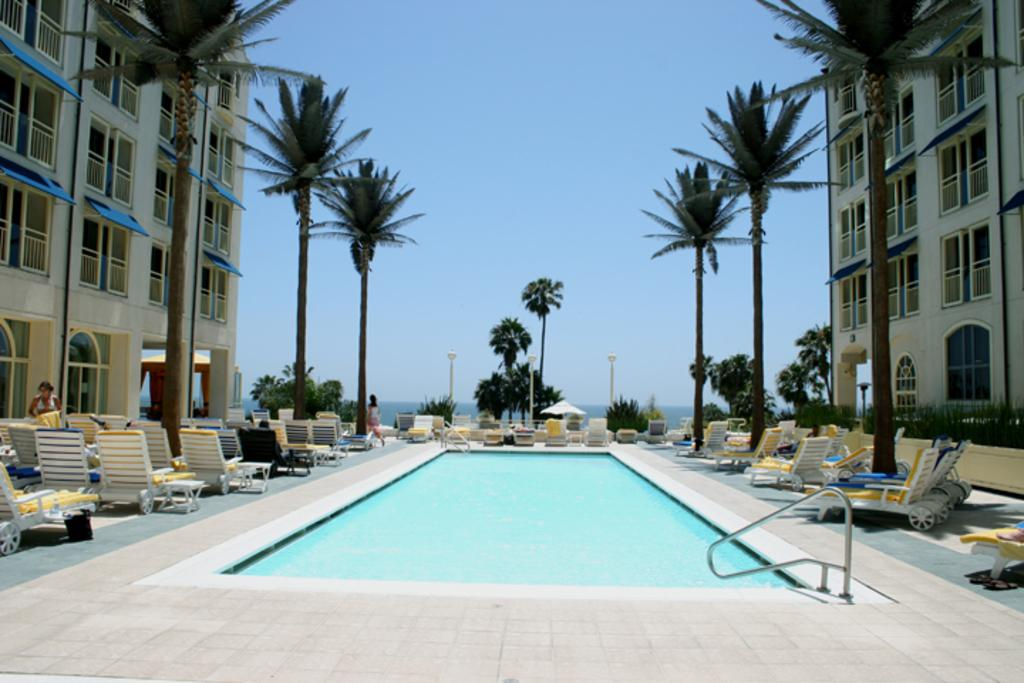What is the main feature in the image? There is a swimming pool in the image. What can be seen in the background of the image? Trees and buildings are visible in the image. Where are the chairs located in the image? There are chairs on both the left and right sides of the image. What is visible at the top of the image? The sky is visible at the top of the image. What type of wine is being served at the account meeting in the image? There is no wine or account meeting present in the image; it features a swimming pool, trees, buildings, and chairs. 